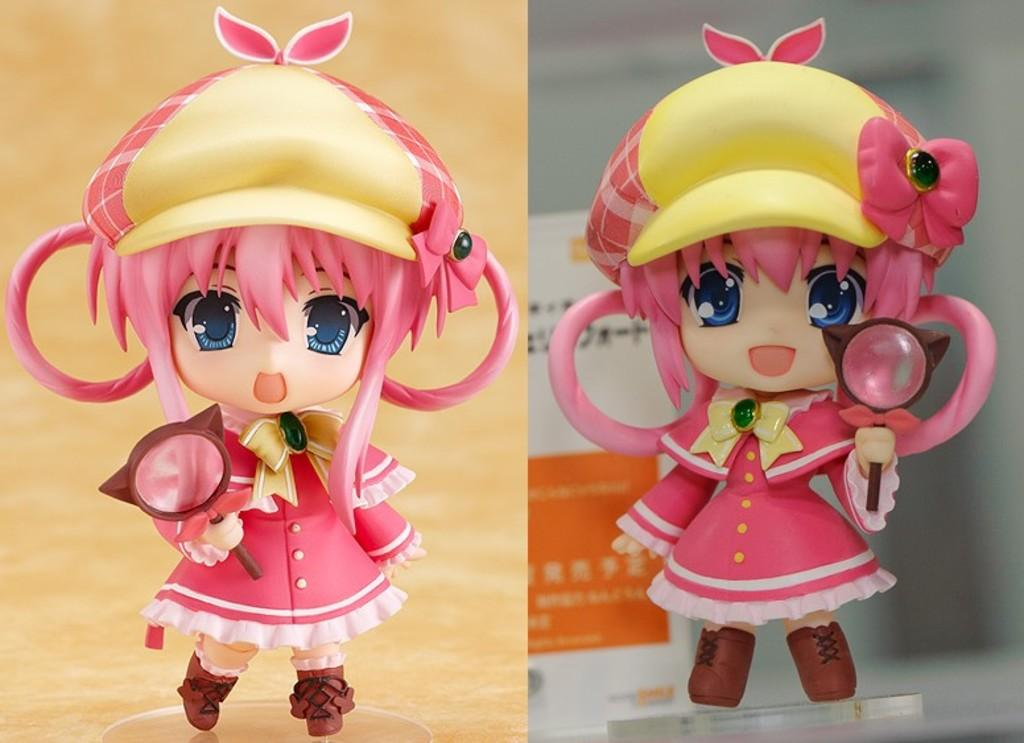What type of artwork is depicted in the image? The image is a collage. What objects can be seen in the collage? There are toys in the image. What is located in the background of the collage? There is a board in the background of the image. What supports the collage at the bottom? There is a stand at the bottom of the image. How many tigers are visible in the image? There are no tigers present in the image. What type of plants can be seen growing in the collage? There are no plants visible in the collage; it is a collection of toys and other objects. 